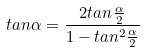Convert formula to latex. <formula><loc_0><loc_0><loc_500><loc_500>t a n \alpha = \frac { 2 t a n \frac { \alpha } { 2 } } { 1 - t a n ^ { 2 } \frac { \alpha } { 2 } }</formula> 